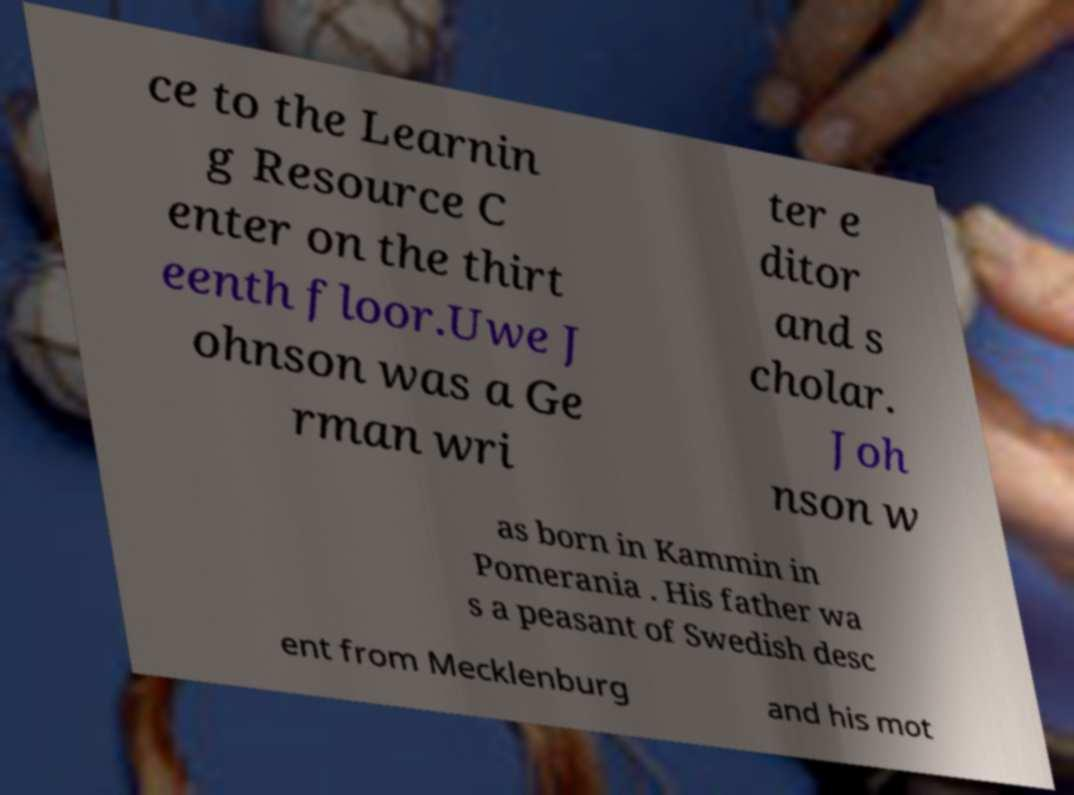Can you read and provide the text displayed in the image?This photo seems to have some interesting text. Can you extract and type it out for me? ce to the Learnin g Resource C enter on the thirt eenth floor.Uwe J ohnson was a Ge rman wri ter e ditor and s cholar. Joh nson w as born in Kammin in Pomerania . His father wa s a peasant of Swedish desc ent from Mecklenburg and his mot 